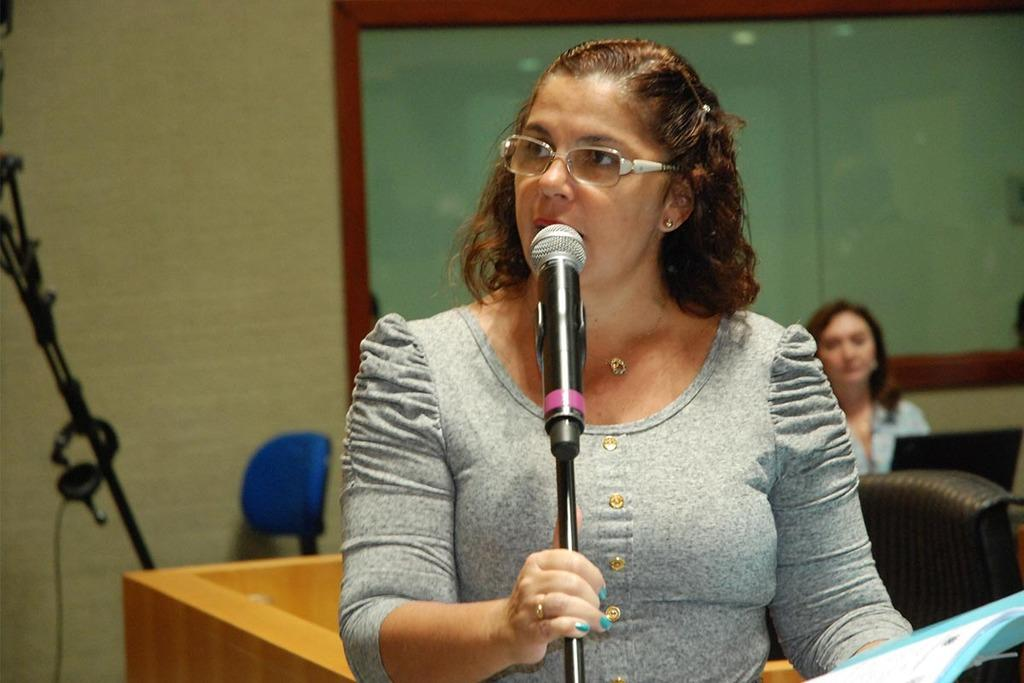What can be seen in the background of the image? There is a board and chairs in the background of the image. Can you describe the woman in the image? The woman has short hair and is wearing spectacles. What is the woman holding in the image? The woman is holding a mike stand with her hand. How many bananas are on the board in the image? There are no bananas present in the image. What type of pin is the woman wearing on her shirt in the image? The woman is not wearing a pin in the image. 